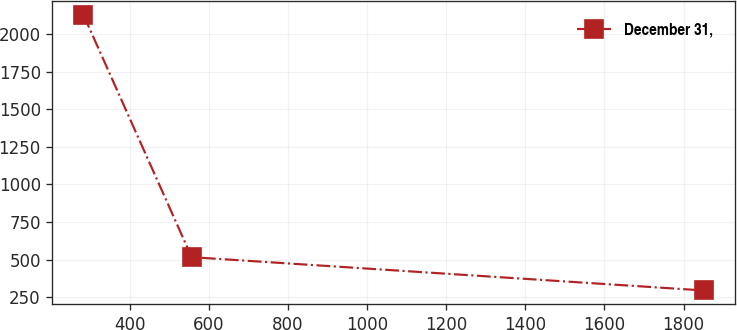Convert chart. <chart><loc_0><loc_0><loc_500><loc_500><line_chart><ecel><fcel>December 31,<nl><fcel>283.29<fcel>2127.47<nl><fcel>556.8<fcel>516.13<nl><fcel>1850.8<fcel>294.79<nl></chart> 